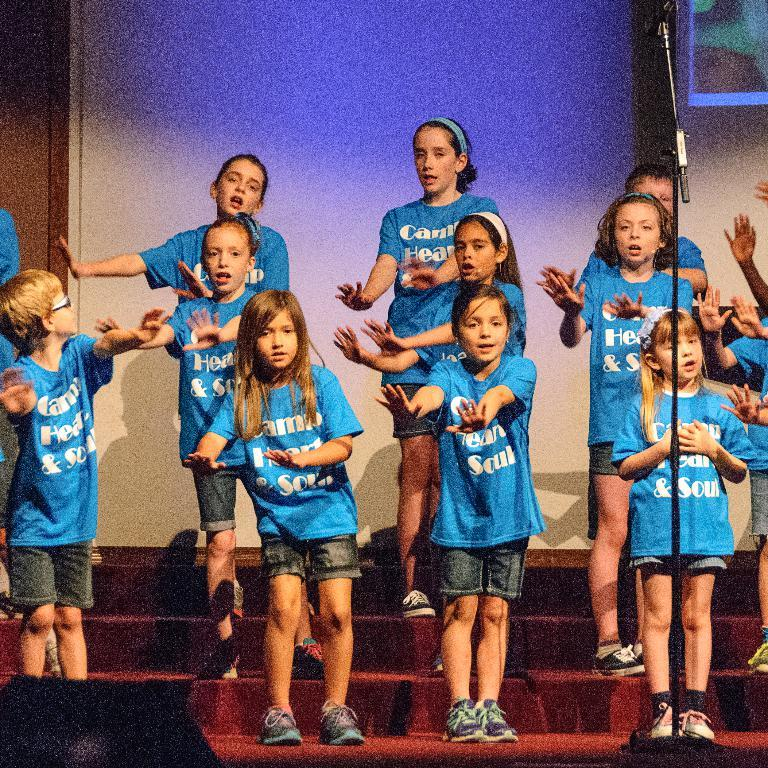What are the kids doing in the image? The kids are standing on the steps in the image. What is in front of the kids? There is a mic on a stand and an object in front of the kids. Can you describe the object in front of the kids? Unfortunately, the facts provided do not give a clear description of the object in front of the kids. What is visible behind the kids? There is a screen visible behind the image behind the kids. What type of education is the kids receiving in the image? The facts provided do not mention any educational context or activity, so it is impossible to determine the type of education the kids are receiving in the image. 